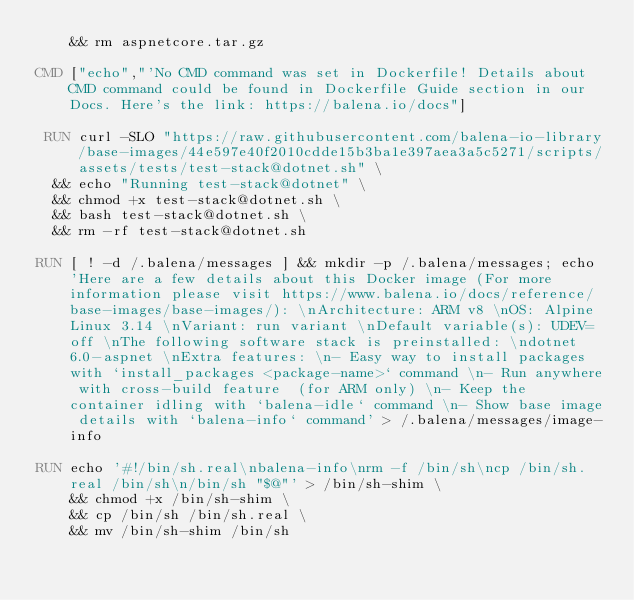<code> <loc_0><loc_0><loc_500><loc_500><_Dockerfile_>    && rm aspnetcore.tar.gz

CMD ["echo","'No CMD command was set in Dockerfile! Details about CMD command could be found in Dockerfile Guide section in our Docs. Here's the link: https://balena.io/docs"]

 RUN curl -SLO "https://raw.githubusercontent.com/balena-io-library/base-images/44e597e40f2010cdde15b3ba1e397aea3a5c5271/scripts/assets/tests/test-stack@dotnet.sh" \
  && echo "Running test-stack@dotnet" \
  && chmod +x test-stack@dotnet.sh \
  && bash test-stack@dotnet.sh \
  && rm -rf test-stack@dotnet.sh 

RUN [ ! -d /.balena/messages ] && mkdir -p /.balena/messages; echo 'Here are a few details about this Docker image (For more information please visit https://www.balena.io/docs/reference/base-images/base-images/): \nArchitecture: ARM v8 \nOS: Alpine Linux 3.14 \nVariant: run variant \nDefault variable(s): UDEV=off \nThe following software stack is preinstalled: \ndotnet 6.0-aspnet \nExtra features: \n- Easy way to install packages with `install_packages <package-name>` command \n- Run anywhere with cross-build feature  (for ARM only) \n- Keep the container idling with `balena-idle` command \n- Show base image details with `balena-info` command' > /.balena/messages/image-info

RUN echo '#!/bin/sh.real\nbalena-info\nrm -f /bin/sh\ncp /bin/sh.real /bin/sh\n/bin/sh "$@"' > /bin/sh-shim \
	&& chmod +x /bin/sh-shim \
	&& cp /bin/sh /bin/sh.real \
	&& mv /bin/sh-shim /bin/sh</code> 